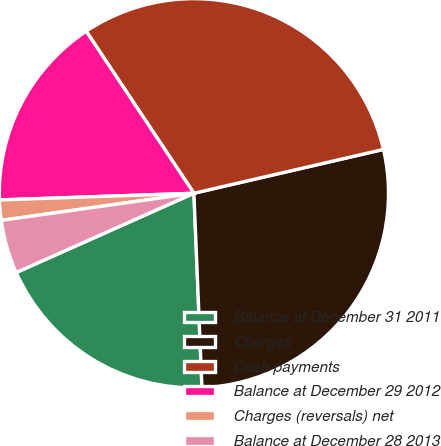Convert chart. <chart><loc_0><loc_0><loc_500><loc_500><pie_chart><fcel>Balance at December 31 2011<fcel>Charges<fcel>Cash payments<fcel>Balance at December 29 2012<fcel>Charges (reversals) net<fcel>Balance at December 28 2013<nl><fcel>18.98%<fcel>27.96%<fcel>30.72%<fcel>16.21%<fcel>1.68%<fcel>4.45%<nl></chart> 